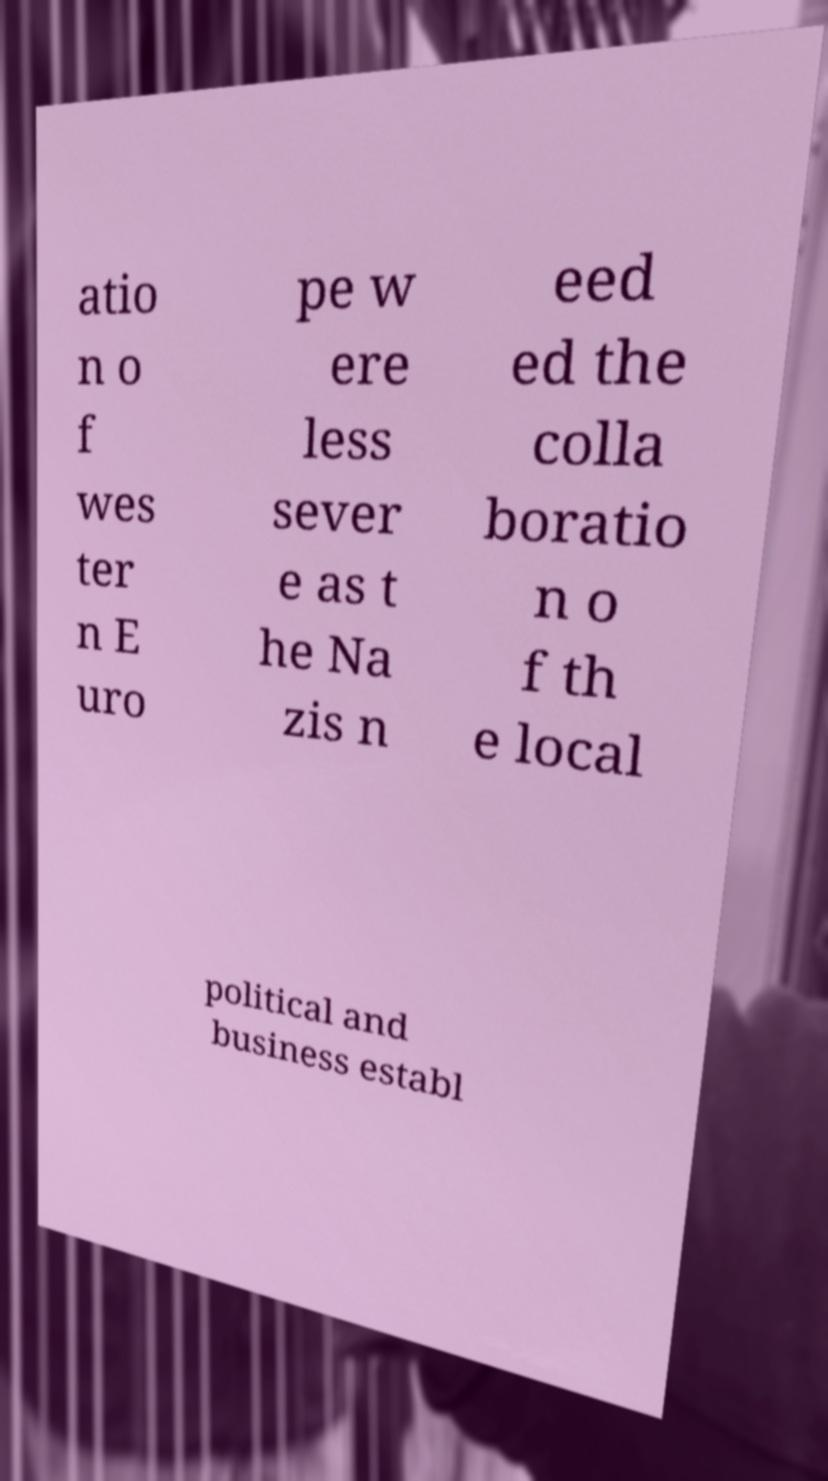Could you extract and type out the text from this image? atio n o f wes ter n E uro pe w ere less sever e as t he Na zis n eed ed the colla boratio n o f th e local political and business establ 